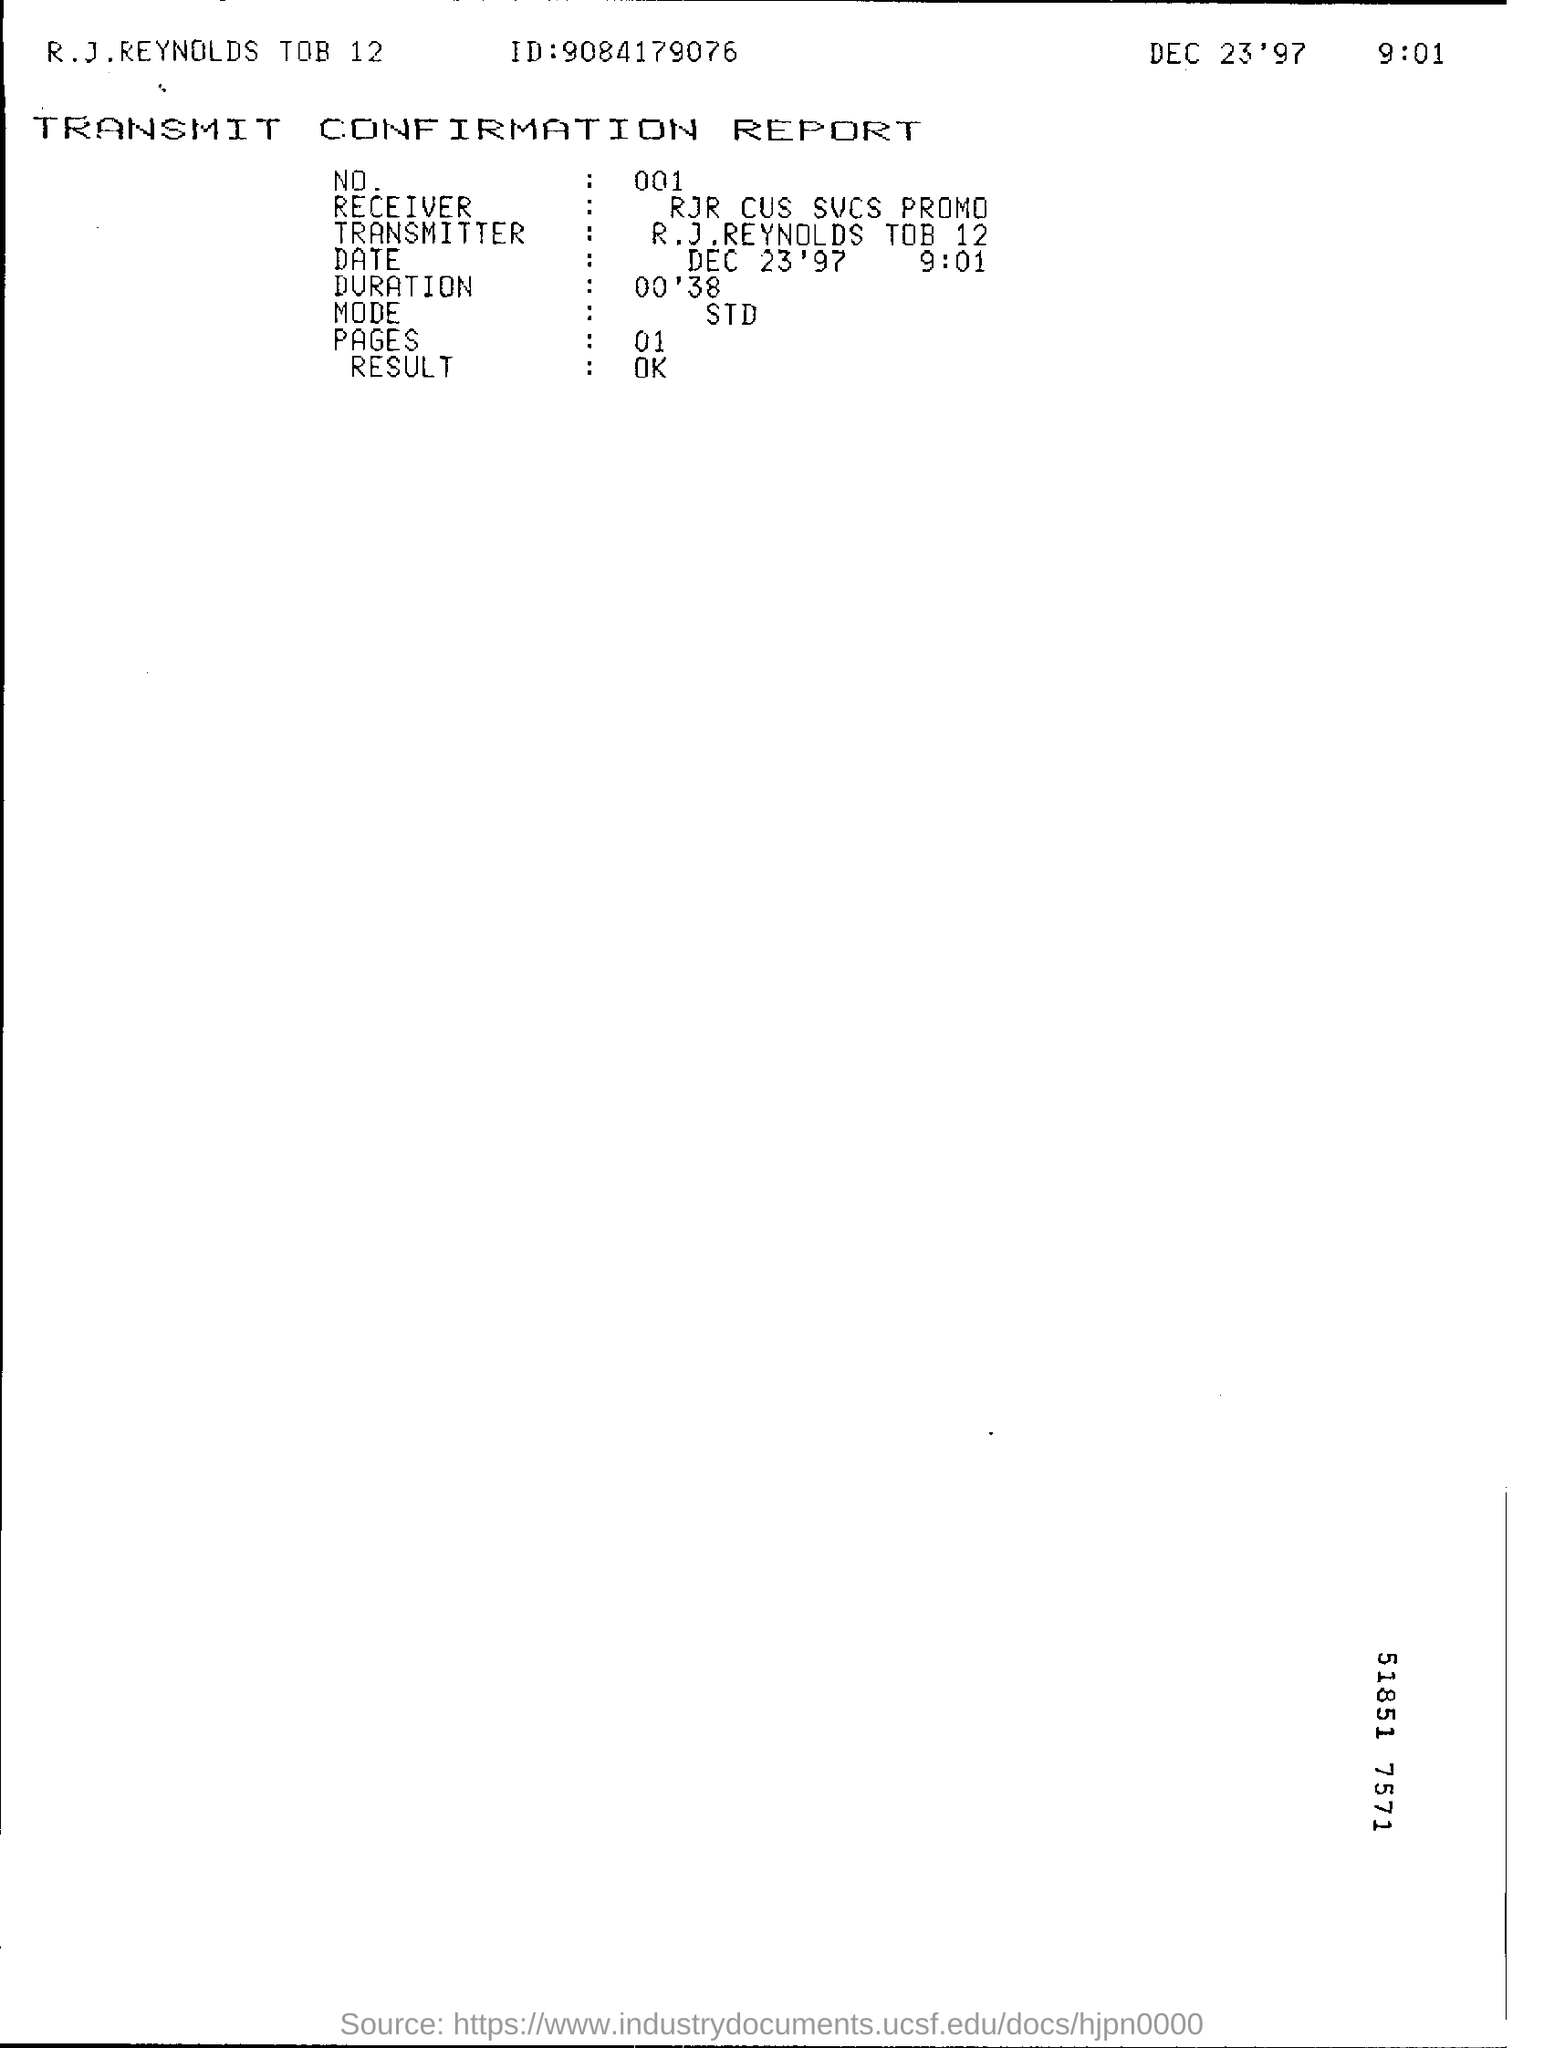Identify some key points in this picture. The result of the report is that it is okay. The name of the receiver of the promotion for RJR Cus Svcs is... The mode of transmission for STDs is unknown. 